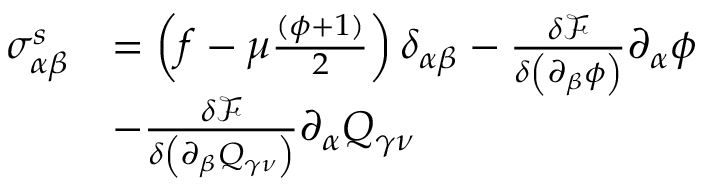Convert formula to latex. <formula><loc_0><loc_0><loc_500><loc_500>\begin{array} { r l } { \sigma _ { \alpha \beta } ^ { s } } & { = \left ( f - \mu \frac { ( \phi + 1 ) } { 2 } \right ) \delta _ { \alpha \beta } - \frac { \delta \mathcal { F } } { \delta \left ( \partial _ { \beta } \phi \right ) } \partial _ { \alpha } \phi } \\ & { - \frac { \delta \mathcal { F } } { \delta \left ( \partial _ { \beta } Q _ { \gamma \nu } \right ) } \partial _ { \alpha } Q _ { \gamma \nu } } \end{array}</formula> 